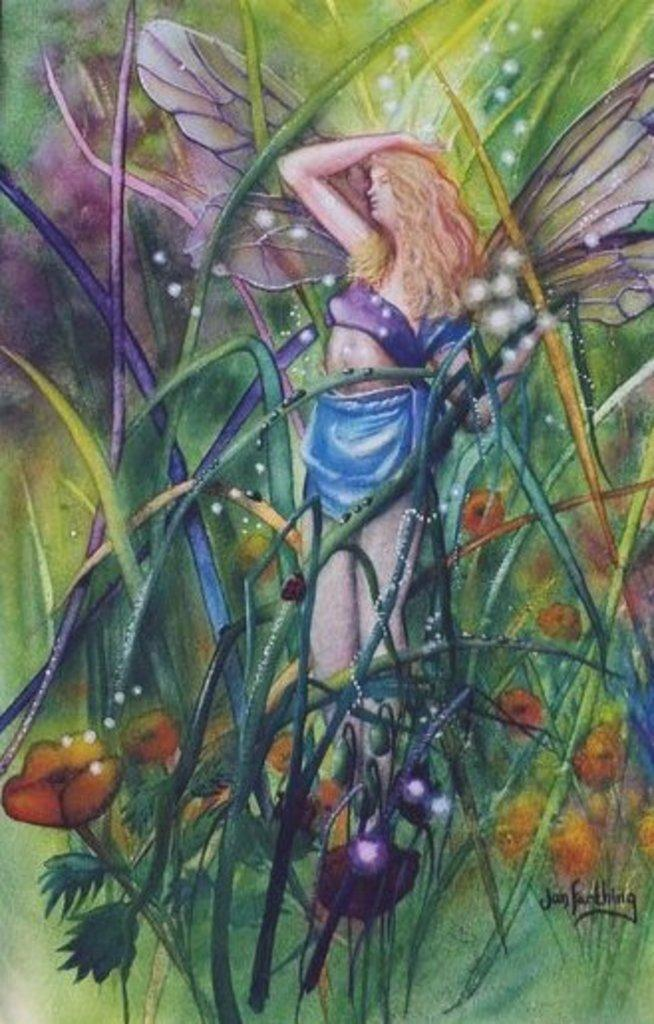What type of artwork is depicted in the image? The image is a painting. Who or what is the main subject of the painting? There is a woman in the painting. What distinguishing feature does the woman have? The woman has wings. What type of natural elements are present in the painting? There are plants and flowers in the painting. Where is the text located in the painting? The text is at the bottom right of the painting. Can you describe the rod that the woman is holding in the painting? There is no rod present in the painting; the woman has wings instead. What type of ocean can be seen in the background of the painting? There is no ocean present in the painting; it features plants, flowers, and a woman with wings. 